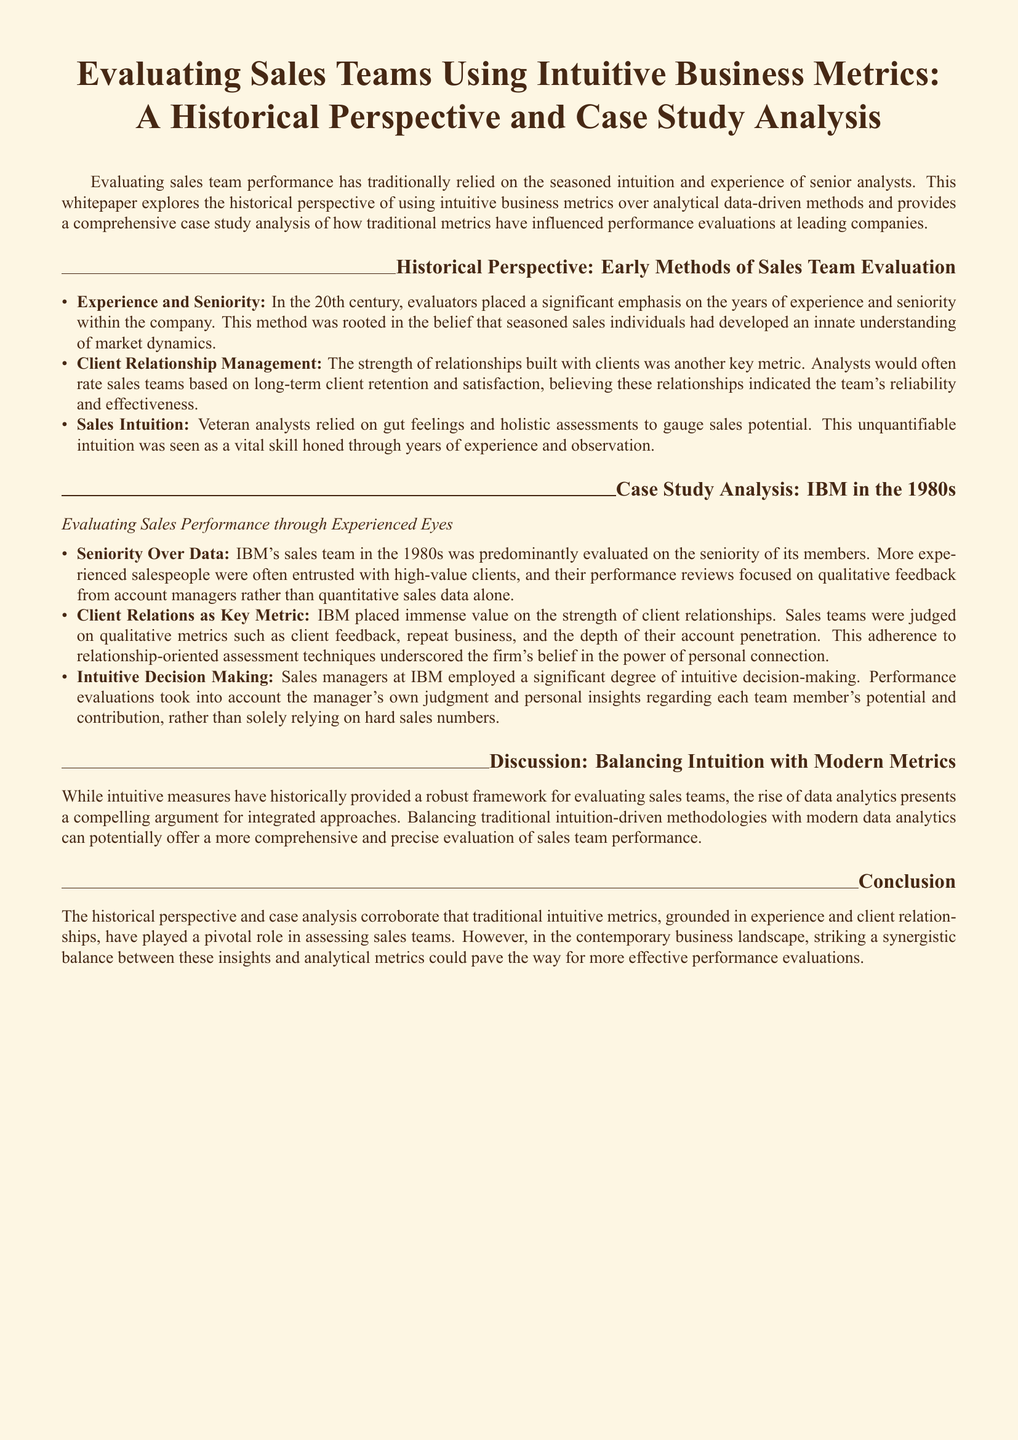what is the title of the whitepaper? The title of the whitepaper is explicitly stated at the beginning.
Answer: Evaluating Sales Teams Using Intuitive Business Metrics: A Historical Perspective and Case Study Analysis what era does the historical perspective cover? The historical perspective mentions the 20th century as the relevant time frame for evaluating sales team performance.
Answer: 20th century which company's sales team is analyzed in the case study? The document specifically provides a case study analysis concerning the sales team of IBM.
Answer: IBM what metric was emphasized for evaluating sales teams in the 1980s? The document highlights client relationships as a crucial metric during the evaluation of sales teams at IBM.
Answer: Client Relations what method of evaluation was predominantly used by IBM's sales team managers? The evaluation method relied significantly on the personal judgment of sales managers according to the document.
Answer: Intuitive Decision Making what key concept is suggested for balancing evaluation methods? The document discusses the importance of balancing traditional intuition-driven methodologies with modern data analytics.
Answer: Balancing intuition with modern metrics which aspect was particularly valued by analysts in the 20th century? Analysts particularly valued the strength of relationships built with clients in their evaluations during the 20th century.
Answer: Client Relationship Management what does the conclusion suggest for performance evaluations? The conclusion suggests that a combination of intuitive insights and analytical metrics could enhance performance evaluations.
Answer: Synergistic balance what skill was considered vital for veteran analysts? The document states that the ability to rely on gut feelings and holistic assessments was considered a vital skill for veteran analysts.
Answer: Sales Intuition 